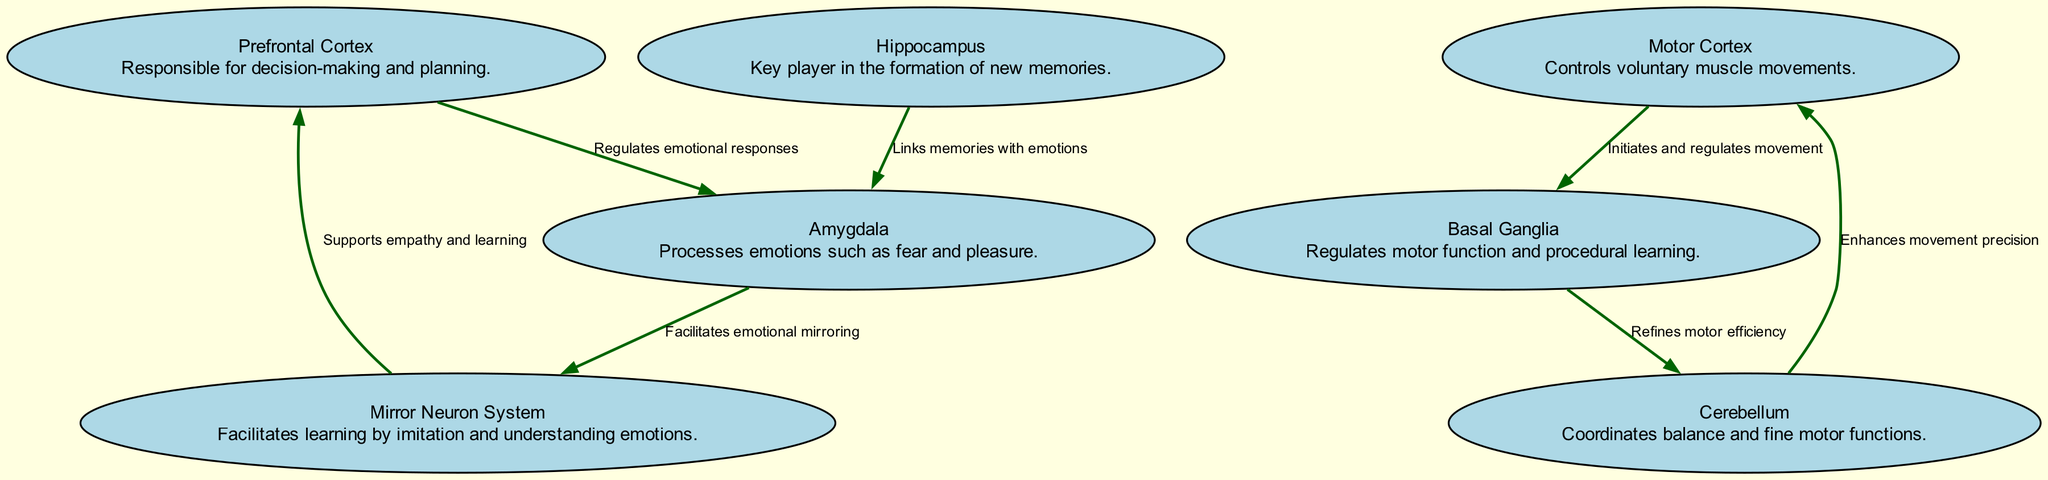What is the role of the hippocampus? The hippocampus is described in the diagram as a "Key player in the formation of new memories." This information indicates its primary function related to memory.
Answer: Key player in the formation of new memories How many nodes are present in the diagram? By counting each unique node in the provided data, we find that there are a total of 7 nodes listed.
Answer: 7 Which node regulates emotional responses? The connection labeled "Regulates emotional responses" shows the interaction from the Prefrontal Cortex to the Amygdala, identifying the Prefrontal Cortex as the regulating node.
Answer: Prefrontal Cortex What does the mirror neuron system support? According to the diagram, the mirror neuron system "Supports empathy and learning." This highlights its importance in social cognition.
Answer: Empathy and learning How do the basal ganglia and cerebellum interact? The relationship is established through two edges: the basal ganglia "Refines motor efficiency" after receiving input from the motor cortex, and the cerebellum enhances movement precision back to the motor cortex, indicating their interdependent functioning.
Answer: Refines motor efficiency What is the connection between the amygdala and the mirror neuron system? The diagram states that the amygdala "Facilitates emotional mirroring" to the mirror neuron system, showing the link between these two components in emotional processing.
Answer: Facilitates emotional mirroring Which structure links memories with emotions? The edge labeled "Links memories with emotions" connects the hippocampus to the amygdala, indicating that the hippocampus is responsible for this function.
Answer: Hippocampus 